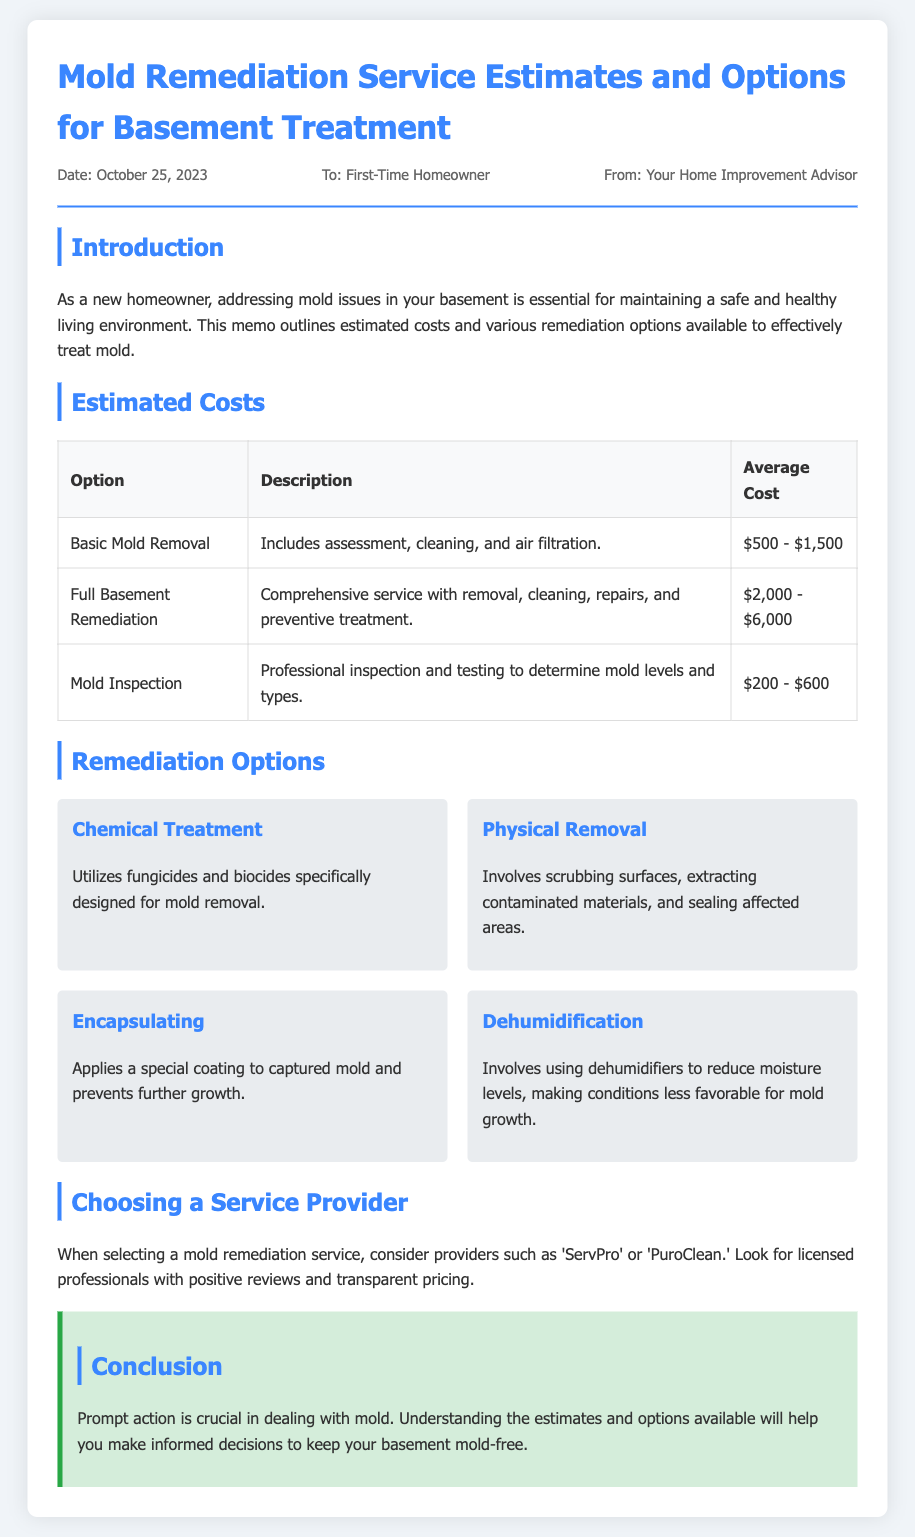What is the date of the memo? The date of the memo is stated clearly in the document, which is October 25, 2023.
Answer: October 25, 2023 What is the average cost range for Basic Mold Removal? The memo specifies the average cost range for Basic Mold Removal as listed in the table.
Answer: $500 - $1,500 Who is the memo addressed to? The recipient of the memo is identified in the meta section of the document.
Answer: First-Time Homeowner What is one of the remediation options mentioned? The document lists several remediation options; one example is given in the remediation options section.
Answer: Chemical Treatment What is the estimated cost for a Mold Inspection? The estimated cost for a Mold Inspection is provided in the cost table of the document.
Answer: $200 - $600 What type of service does Full Basement Remediation include? The memo describes Full Basement Remediation in terms of what it covers in the description.
Answer: Removal, cleaning, repairs, and preventive treatment What should you consider when choosing a service provider? The conclusion section mentions key factors for selecting a service provider, which guides the homeowner.
Answer: Licensed professionals with positive reviews What is the purpose of the memo? The introduction section clearly states the purpose of the memo regarding basement mold issues.
Answer: Addressing mold issues in the basement 